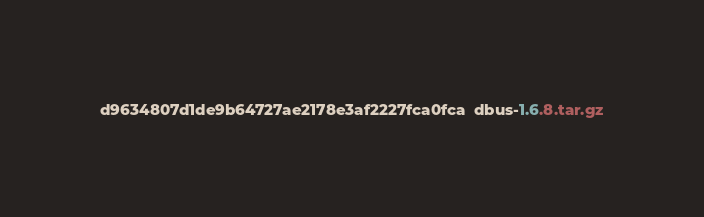<code> <loc_0><loc_0><loc_500><loc_500><_SML_>d9634807d1de9b64727ae2178e3af2227fca0fca  dbus-1.6.8.tar.gz
</code> 